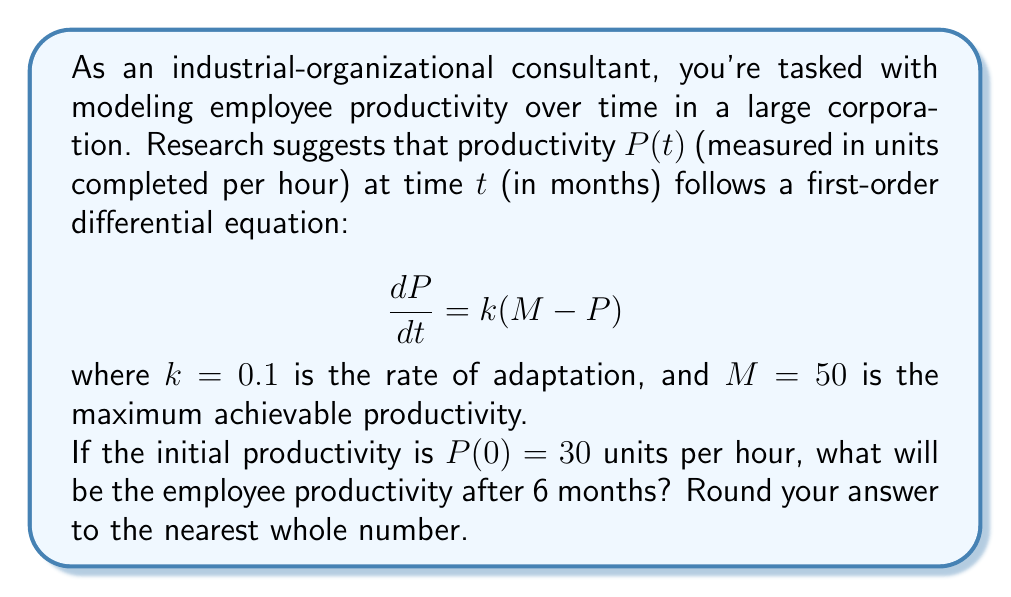Provide a solution to this math problem. To solve this first-order differential equation, we'll follow these steps:

1) The general solution for this type of differential equation is:
   $$P(t) = M + (P(0) - M)e^{-kt}$$

2) We're given:
   $k = 0.1$
   $M = 50$
   $P(0) = 30$
   $t = 6$ (we want to find P after 6 months)

3) Let's substitute these values into our general solution:
   $$P(6) = 50 + (30 - 50)e^{-0.1(6)}$$

4) Simplify:
   $$P(6) = 50 - 20e^{-0.6}$$

5) Calculate $e^{-0.6}$:
   $$e^{-0.6} \approx 0.5488$$

6) Now we can compute P(6):
   $$P(6) = 50 - 20(0.5488) = 50 - 10.976 = 39.024$$

7) Rounding to the nearest whole number:
   $$P(6) \approx 39$$ units per hour
Answer: 39 units per hour 